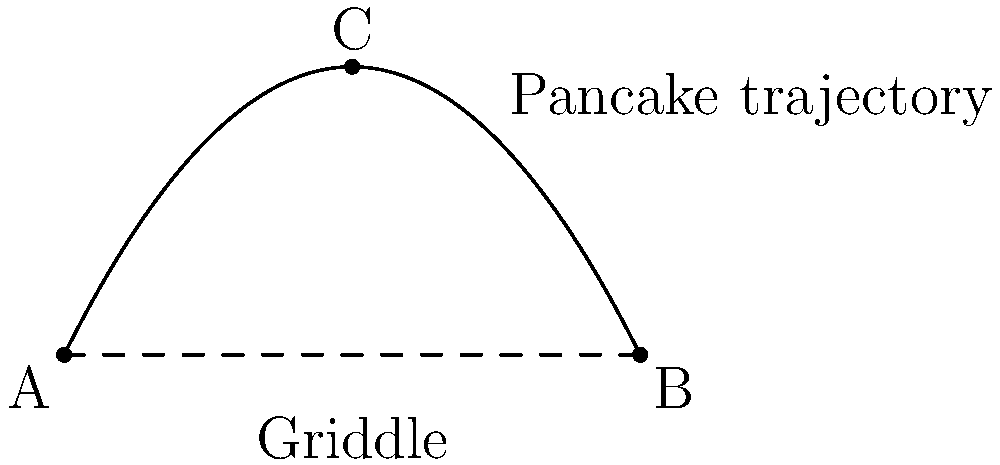As the organizer of a weekly breakfast club, you're demonstrating pancake flipping techniques. If a pancake is flipped from point A to point B on a griddle that's 1 meter long, and reaches a maximum height of 0.5 meters at point C, what is the total distance traveled by the pancake along its parabolic path? Let's approach this step-by-step:

1) The parabolic path of the pancake can be described by the equation:
   $y = -ax^2 + bx$, where $a$ and $b$ are constants we need to determine.

2) We know three points on this path:
   A(0,0), B(1,0), and C(0.5,0.5)

3) Using point C, we can write:
   $0.5 = -a(0.5)^2 + b(0.5)$
   $0.5 = -0.25a + 0.5b$ ... (1)

4) Using point B:
   $0 = -a(1)^2 + b(1)$
   $a = b$ ... (2)

5) Substituting (2) into (1):
   $0.5 = -0.25a + 0.5a$
   $0.5 = 0.25a$
   $a = 2$ and $b = 2$

6) So our parabola equation is: $y = -2x^2 + 2x$

7) To find the length of this curve, we use the arc length formula:
   $L = \int_0^1 \sqrt{1 + (y')^2} dx$

8) $y' = -4x + 2$

9) Substituting into the formula:
   $L = \int_0^1 \sqrt{1 + (-4x + 2)^2} dx$

10) This integral doesn't have a simple analytical solution, so we'd typically use numerical integration methods. Using a calculator or computer, we get:

    $L \approx 1.1487$ meters
Answer: $1.15$ meters (rounded to two decimal places) 